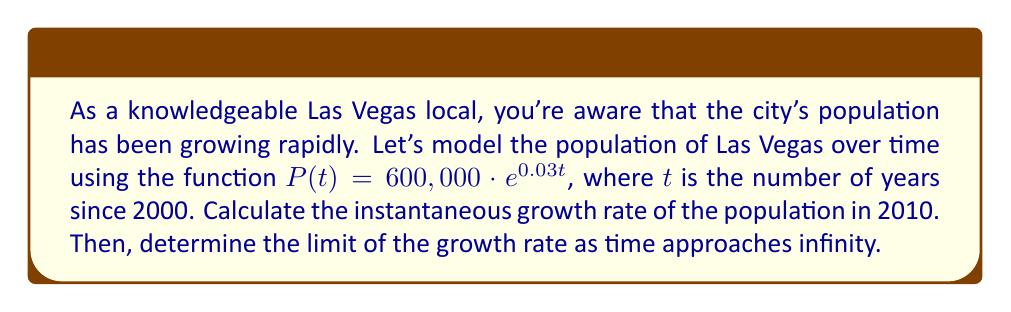Solve this math problem. To solve this problem, we'll use derivatives to find the instantaneous growth rate and limits to analyze the long-term behavior.

1. Instantaneous growth rate in 2010:
   The instantaneous growth rate is given by the derivative of the population function.

   $$\frac{dP}{dt} = 600,000 \cdot 0.03 \cdot e^{0.03t}$$

   To find the growth rate in 2010, we need to evaluate this at $t = 10$ (since 2010 is 10 years after 2000):

   $$\left.\frac{dP}{dt}\right|_{t=10} = 600,000 \cdot 0.03 \cdot e^{0.03 \cdot 10}$$
   $$= 18,000 \cdot e^{0.3}$$
   $$\approx 24,428.96$$

   This means the population is growing at a rate of about 24,429 people per year in 2010.

2. Limit of the growth rate as time approaches infinity:
   To find this, we need to evaluate the limit of the derivative as $t$ approaches infinity:

   $$\lim_{t \to \infty} \frac{dP}{dt} = \lim_{t \to \infty} 600,000 \cdot 0.03 \cdot e^{0.03t}$$

   As $t$ approaches infinity, $e^{0.03t}$ grows without bound. Therefore:

   $$\lim_{t \to \infty} \frac{dP}{dt} = \infty$$

   This indicates that the growth rate increases without bound as time goes on, according to this model.
Answer: The instantaneous growth rate in 2010 is approximately 24,429 people per year. The limit of the growth rate as time approaches infinity is $\infty$. 